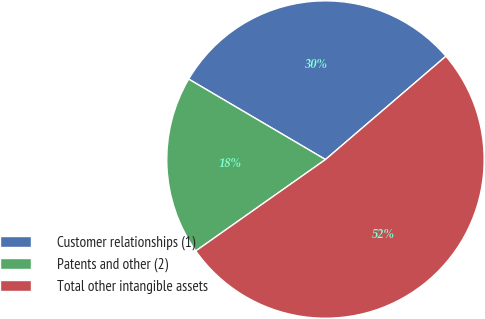Convert chart. <chart><loc_0><loc_0><loc_500><loc_500><pie_chart><fcel>Customer relationships (1)<fcel>Patents and other (2)<fcel>Total other intangible assets<nl><fcel>30.25%<fcel>18.23%<fcel>51.51%<nl></chart> 